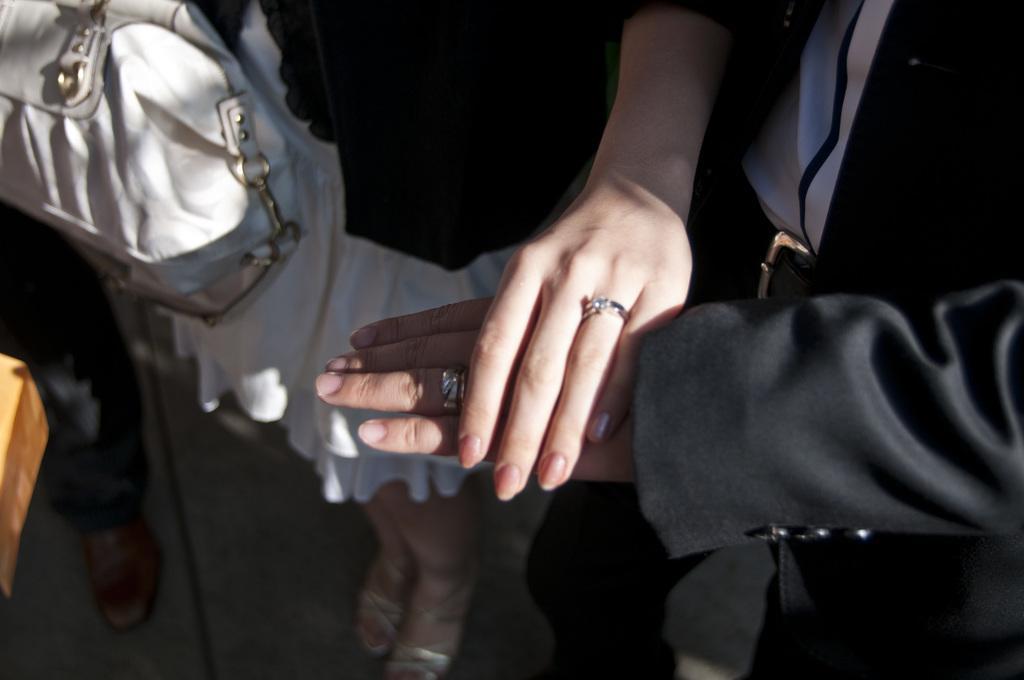Please provide a concise description of this image. Woman in black and white dress is putting her hand on the hand of man wearing black blazer and beside her, we see a white bag and beside that, we see the leg of a person. 